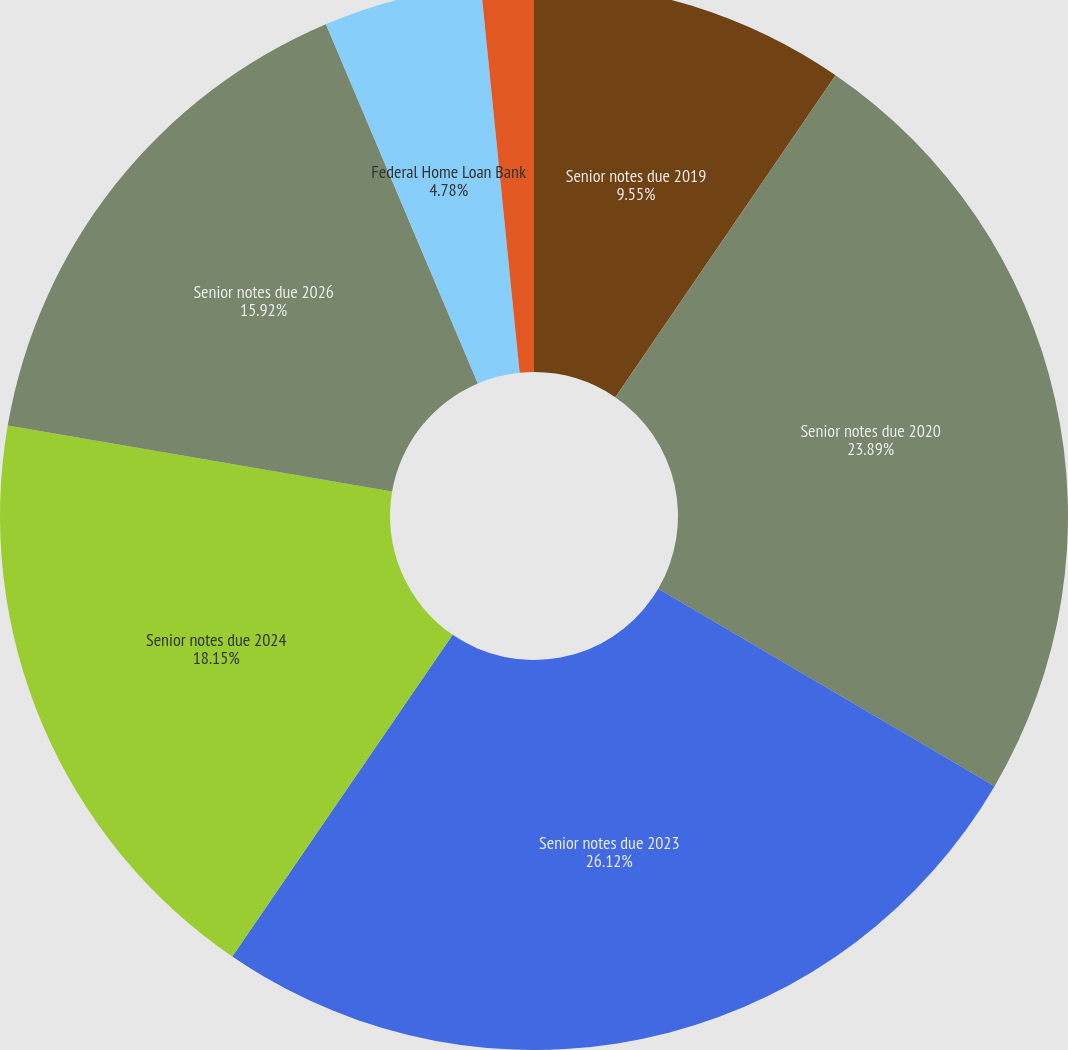<chart> <loc_0><loc_0><loc_500><loc_500><pie_chart><fcel>Senior notes due 2019<fcel>Senior notes due 2020<fcel>Senior notes due 2023<fcel>Senior notes due 2024<fcel>Senior notes due 2026<fcel>Federal Home Loan Bank<fcel>Repurchase agreements<nl><fcel>9.55%<fcel>23.89%<fcel>26.11%<fcel>18.15%<fcel>15.92%<fcel>4.78%<fcel>1.59%<nl></chart> 